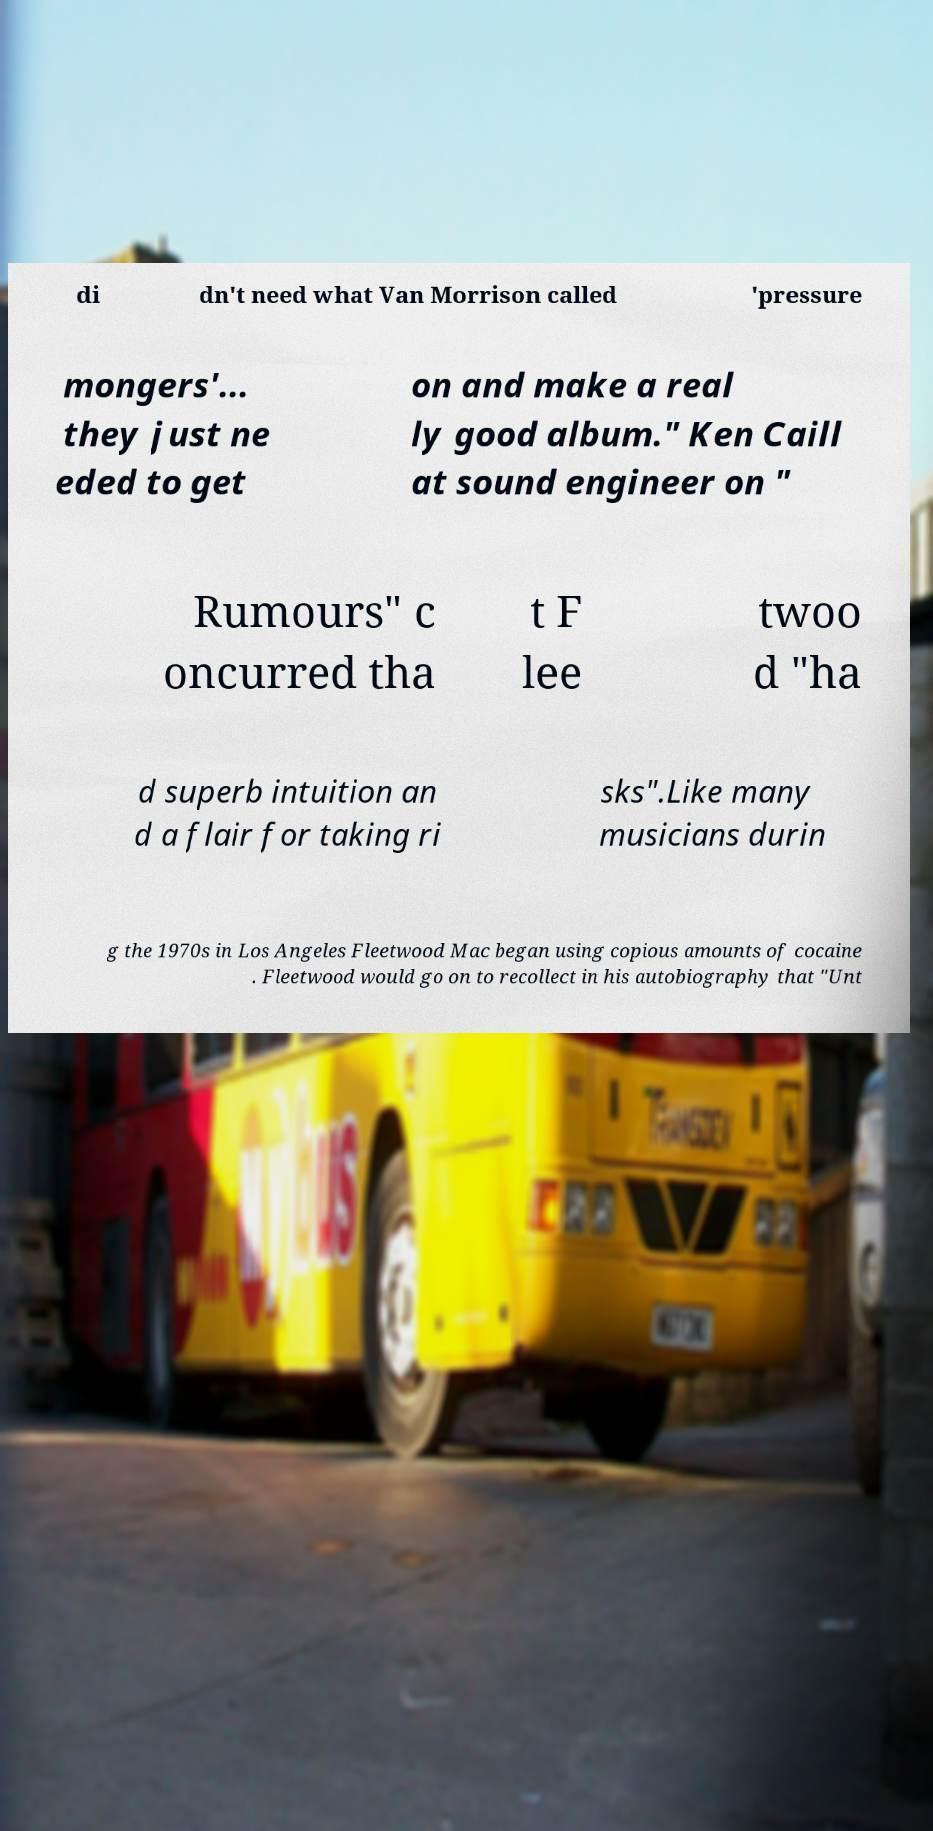There's text embedded in this image that I need extracted. Can you transcribe it verbatim? di dn't need what Van Morrison called 'pressure mongers'... they just ne eded to get on and make a real ly good album." Ken Caill at sound engineer on " Rumours" c oncurred tha t F lee twoo d "ha d superb intuition an d a flair for taking ri sks".Like many musicians durin g the 1970s in Los Angeles Fleetwood Mac began using copious amounts of cocaine . Fleetwood would go on to recollect in his autobiography that "Unt 